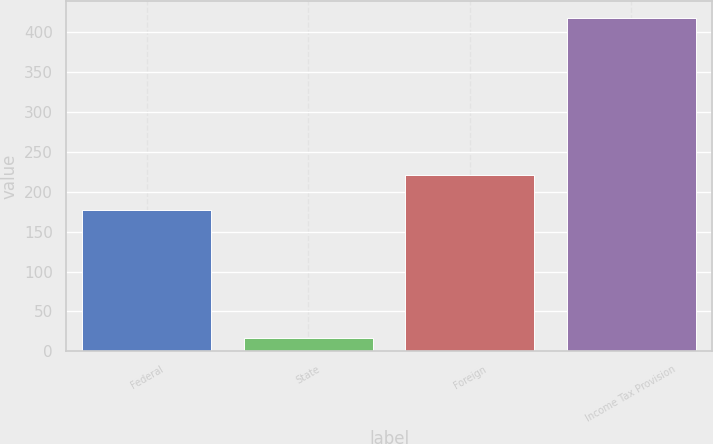<chart> <loc_0><loc_0><loc_500><loc_500><bar_chart><fcel>Federal<fcel>State<fcel>Foreign<fcel>Income Tax Provision<nl><fcel>177.1<fcel>16.9<fcel>221.4<fcel>418.3<nl></chart> 